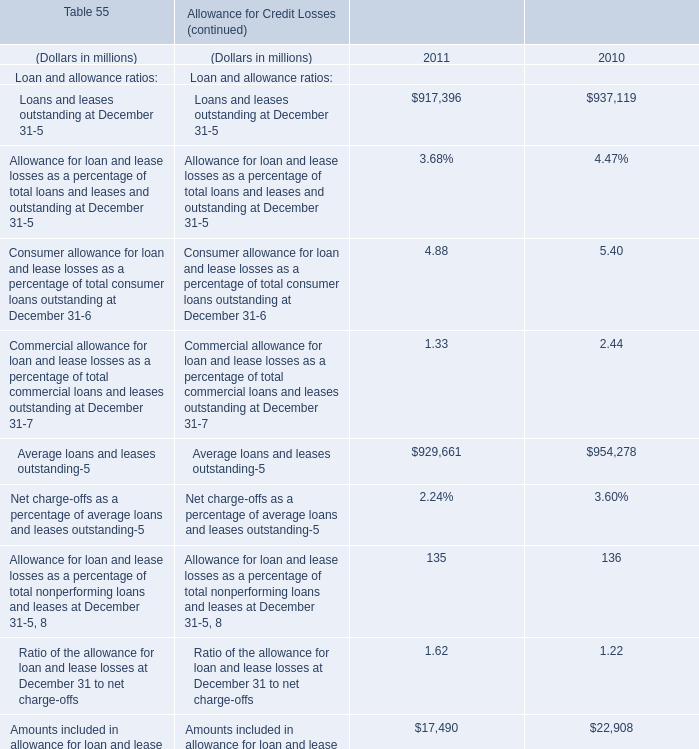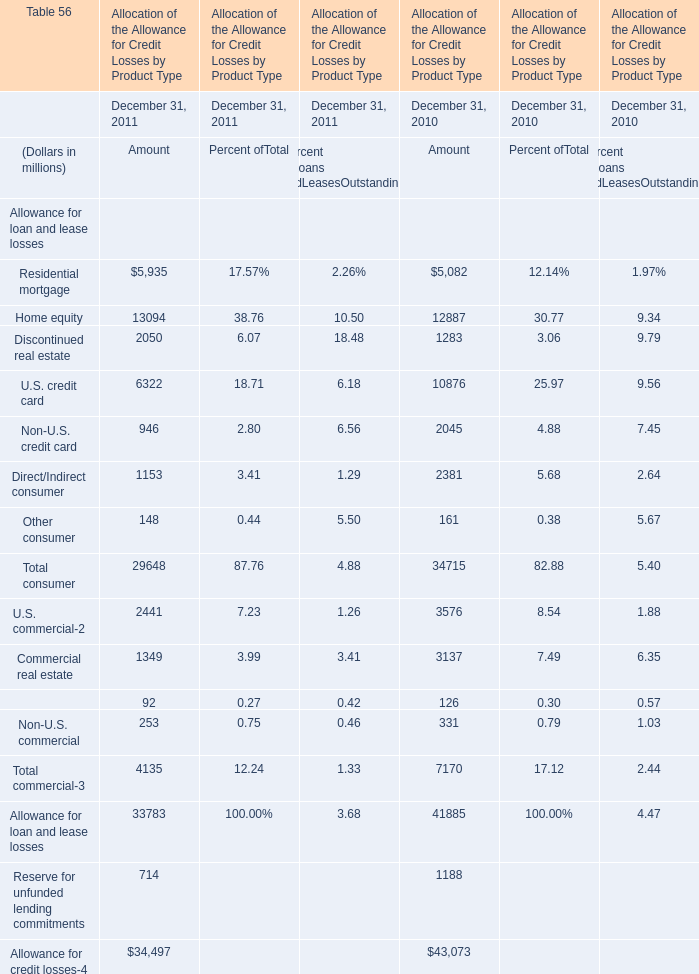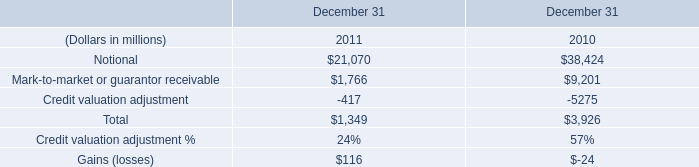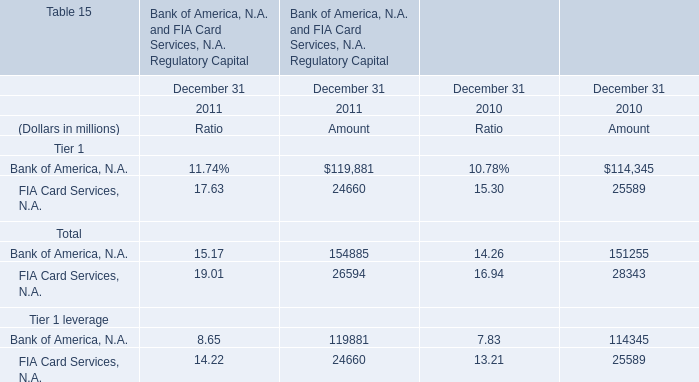What's the growth rate of Average loans and leases outstanding in 2011? (in %) 
Computations: ((929661 - 954278) / 954278)
Answer: -0.0258. 